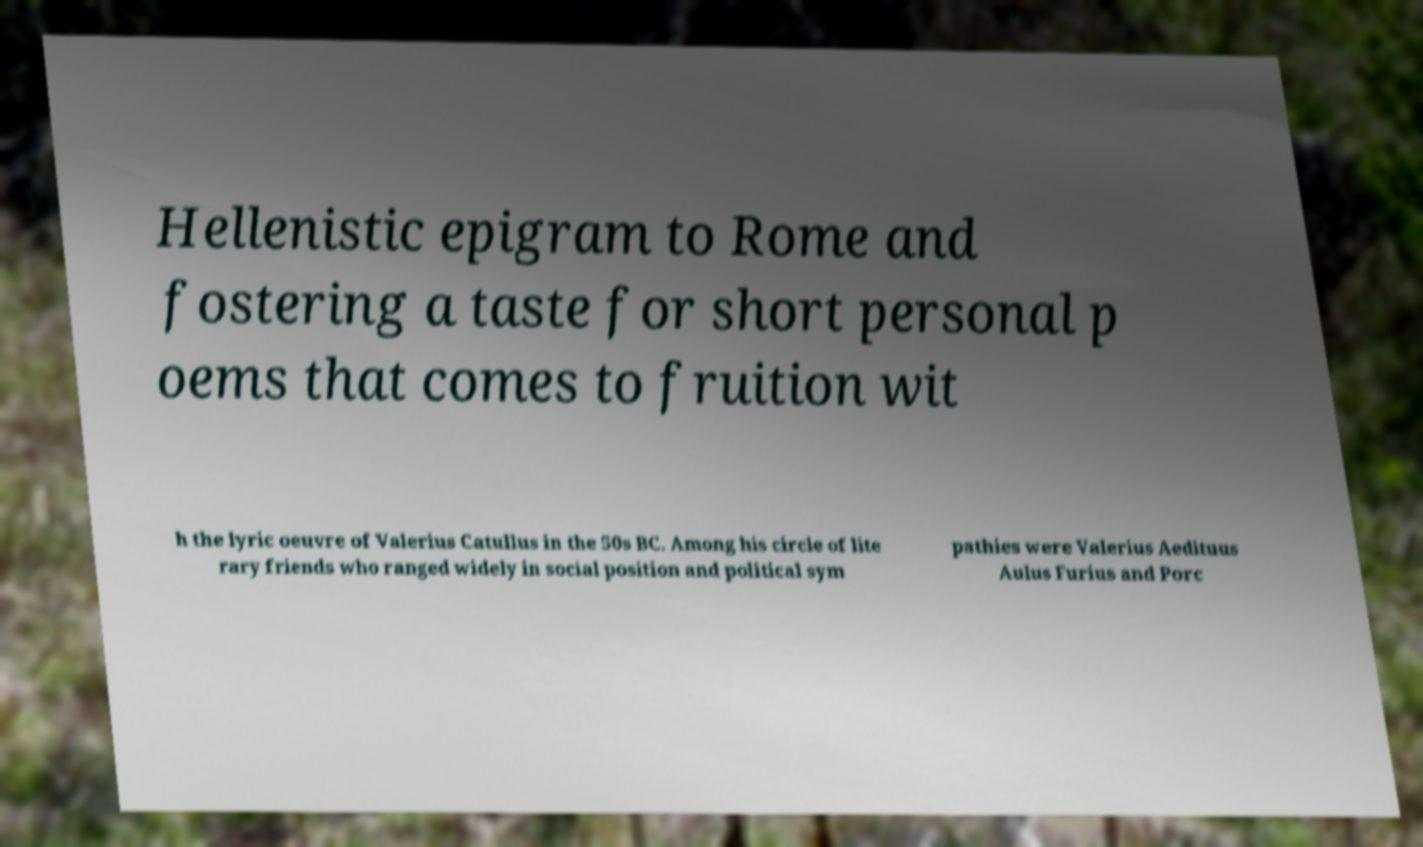Could you extract and type out the text from this image? Hellenistic epigram to Rome and fostering a taste for short personal p oems that comes to fruition wit h the lyric oeuvre of Valerius Catullus in the 50s BC. Among his circle of lite rary friends who ranged widely in social position and political sym pathies were Valerius Aedituus Aulus Furius and Porc 